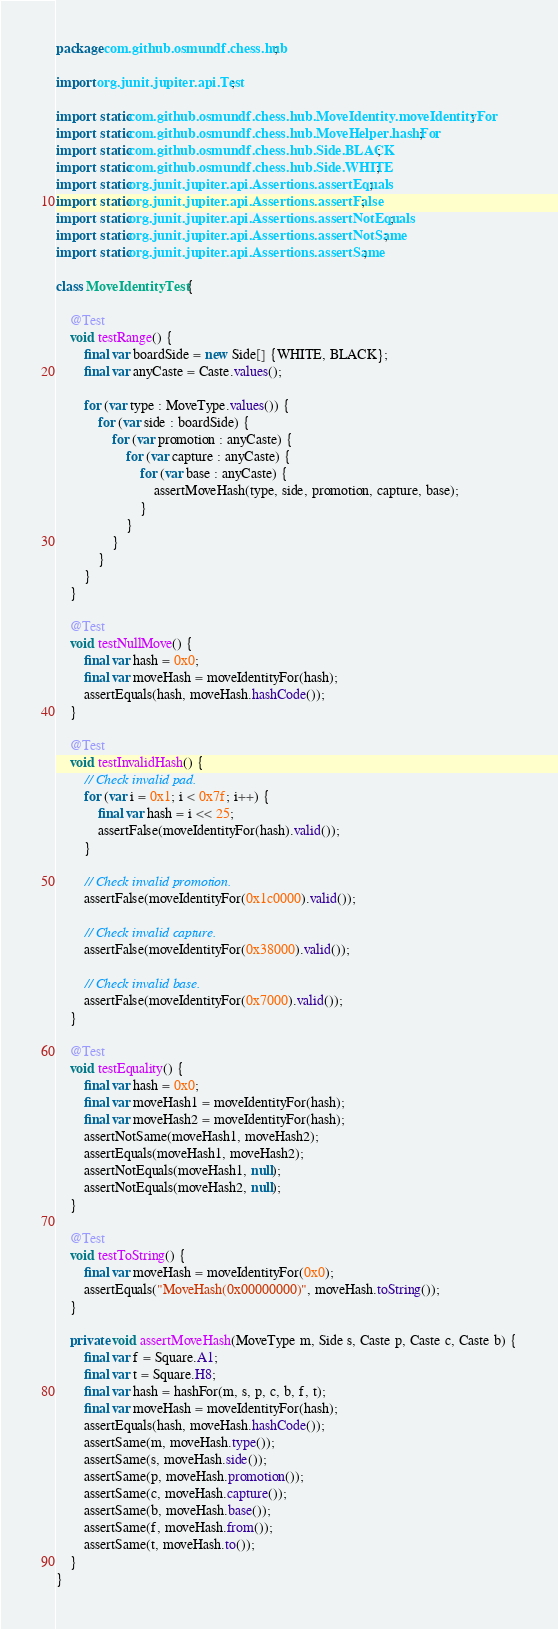<code> <loc_0><loc_0><loc_500><loc_500><_Java_>package com.github.osmundf.chess.hub;

import org.junit.jupiter.api.Test;

import static com.github.osmundf.chess.hub.MoveIdentity.moveIdentityFor;
import static com.github.osmundf.chess.hub.MoveHelper.hashFor;
import static com.github.osmundf.chess.hub.Side.BLACK;
import static com.github.osmundf.chess.hub.Side.WHITE;
import static org.junit.jupiter.api.Assertions.assertEquals;
import static org.junit.jupiter.api.Assertions.assertFalse;
import static org.junit.jupiter.api.Assertions.assertNotEquals;
import static org.junit.jupiter.api.Assertions.assertNotSame;
import static org.junit.jupiter.api.Assertions.assertSame;

class MoveIdentityTest {

    @Test
    void testRange() {
        final var boardSide = new Side[] {WHITE, BLACK};
        final var anyCaste = Caste.values();

        for (var type : MoveType.values()) {
            for (var side : boardSide) {
                for (var promotion : anyCaste) {
                    for (var capture : anyCaste) {
                        for (var base : anyCaste) {
                            assertMoveHash(type, side, promotion, capture, base);
                        }
                    }
                }
            }
        }
    }

    @Test
    void testNullMove() {
        final var hash = 0x0;
        final var moveHash = moveIdentityFor(hash);
        assertEquals(hash, moveHash.hashCode());
    }

    @Test
    void testInvalidHash() {
        // Check invalid pad.
        for (var i = 0x1; i < 0x7f; i++) {
            final var hash = i << 25;
            assertFalse(moveIdentityFor(hash).valid());
        }

        // Check invalid promotion.
        assertFalse(moveIdentityFor(0x1c0000).valid());

        // Check invalid capture.
        assertFalse(moveIdentityFor(0x38000).valid());

        // Check invalid base.
        assertFalse(moveIdentityFor(0x7000).valid());
    }

    @Test
    void testEquality() {
        final var hash = 0x0;
        final var moveHash1 = moveIdentityFor(hash);
        final var moveHash2 = moveIdentityFor(hash);
        assertNotSame(moveHash1, moveHash2);
        assertEquals(moveHash1, moveHash2);
        assertNotEquals(moveHash1, null);
        assertNotEquals(moveHash2, null);
    }

    @Test
    void testToString() {
        final var moveHash = moveIdentityFor(0x0);
        assertEquals("MoveHash(0x00000000)", moveHash.toString());
    }

    private void assertMoveHash(MoveType m, Side s, Caste p, Caste c, Caste b) {
        final var f = Square.A1;
        final var t = Square.H8;
        final var hash = hashFor(m, s, p, c, b, f, t);
        final var moveHash = moveIdentityFor(hash);
        assertEquals(hash, moveHash.hashCode());
        assertSame(m, moveHash.type());
        assertSame(s, moveHash.side());
        assertSame(p, moveHash.promotion());
        assertSame(c, moveHash.capture());
        assertSame(b, moveHash.base());
        assertSame(f, moveHash.from());
        assertSame(t, moveHash.to());
    }
}
</code> 